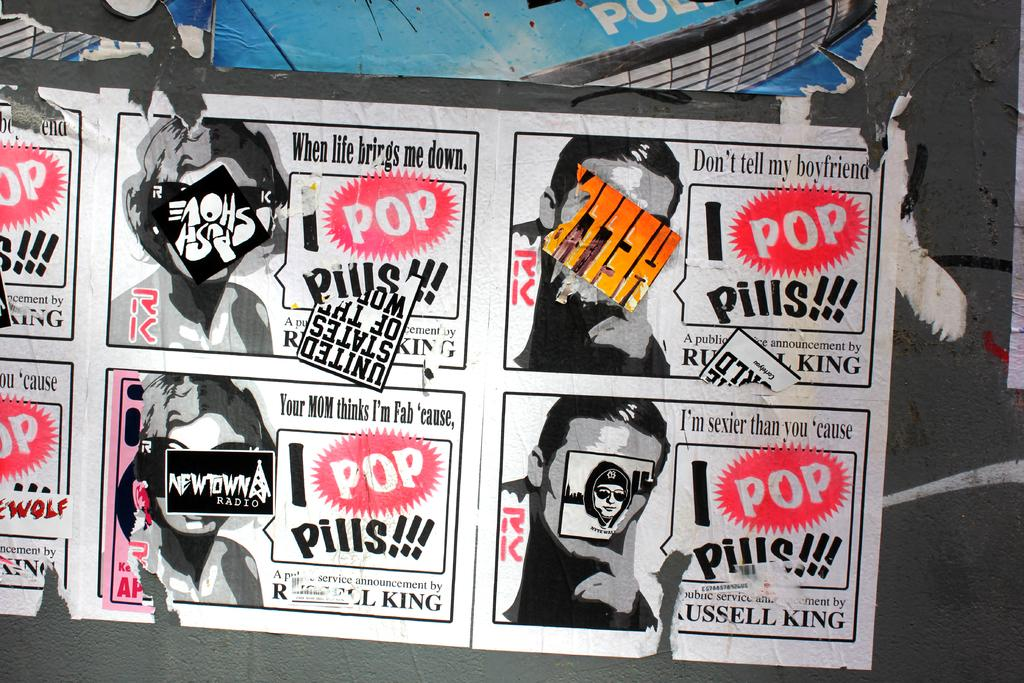What can be seen in the image? There is a poster in the image. What is featured on the poster? There is text written on the poster. How many airplanes are flying in the image? There are no airplanes visible in the image; it only features a poster with text. What type of finger can be seen pointing at the text on the poster? There is no finger present in the image; it only features a poster with text. 